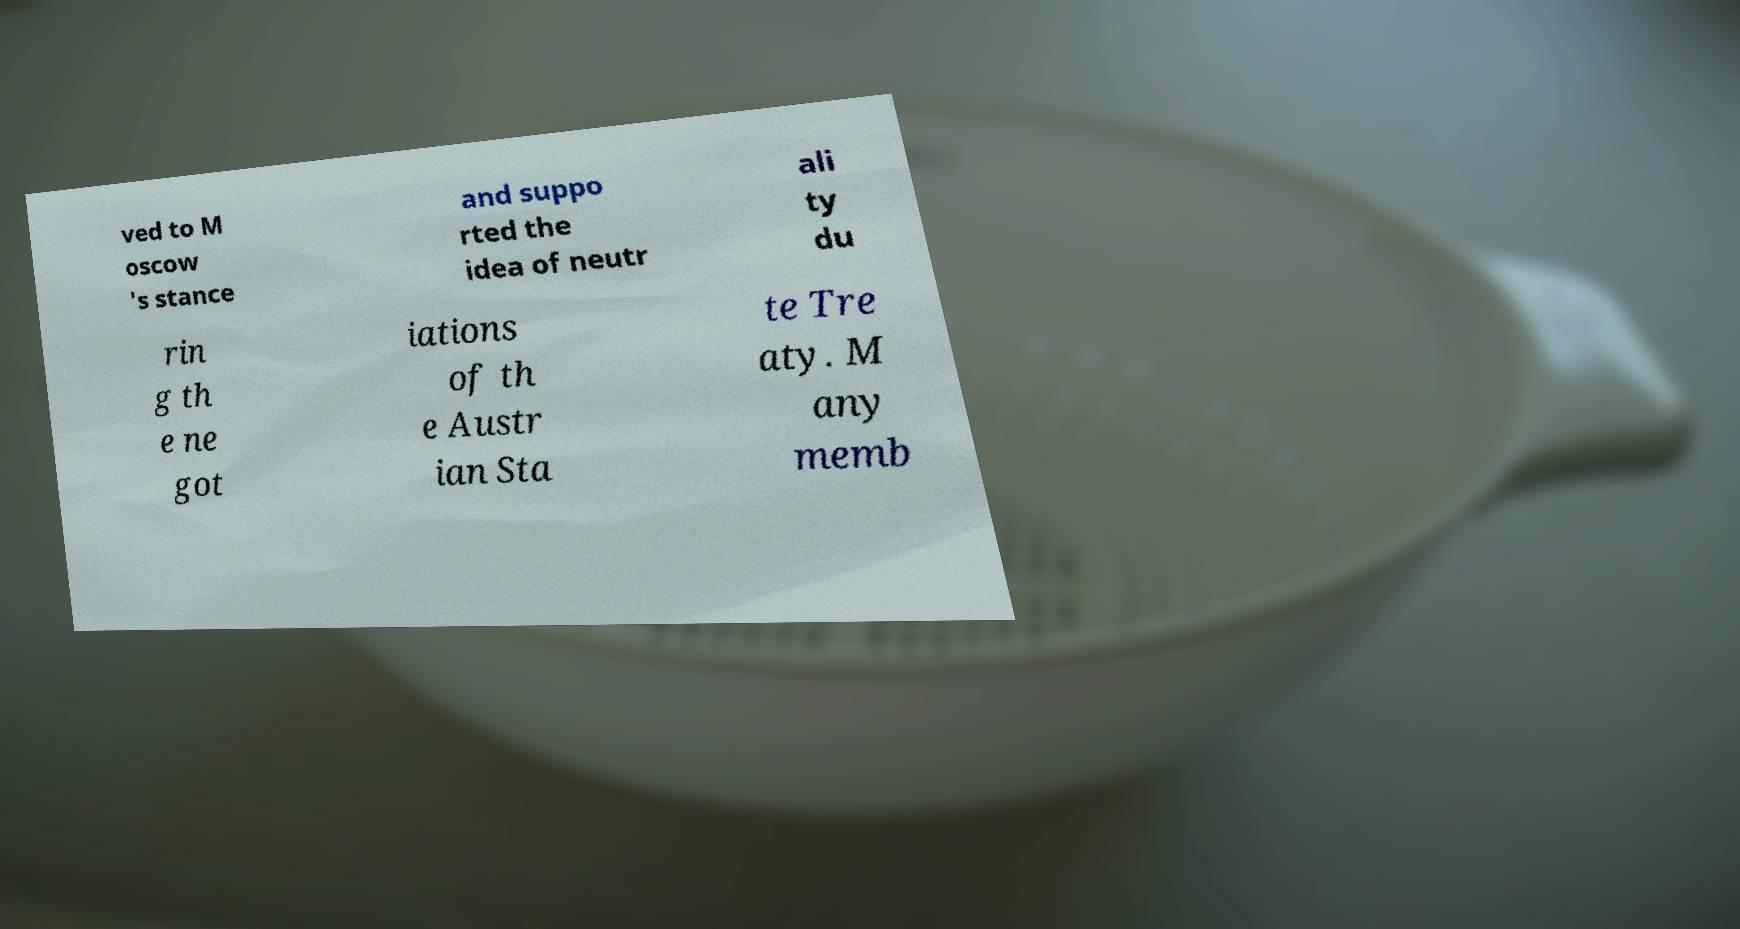For documentation purposes, I need the text within this image transcribed. Could you provide that? ved to M oscow 's stance and suppo rted the idea of neutr ali ty du rin g th e ne got iations of th e Austr ian Sta te Tre aty. M any memb 